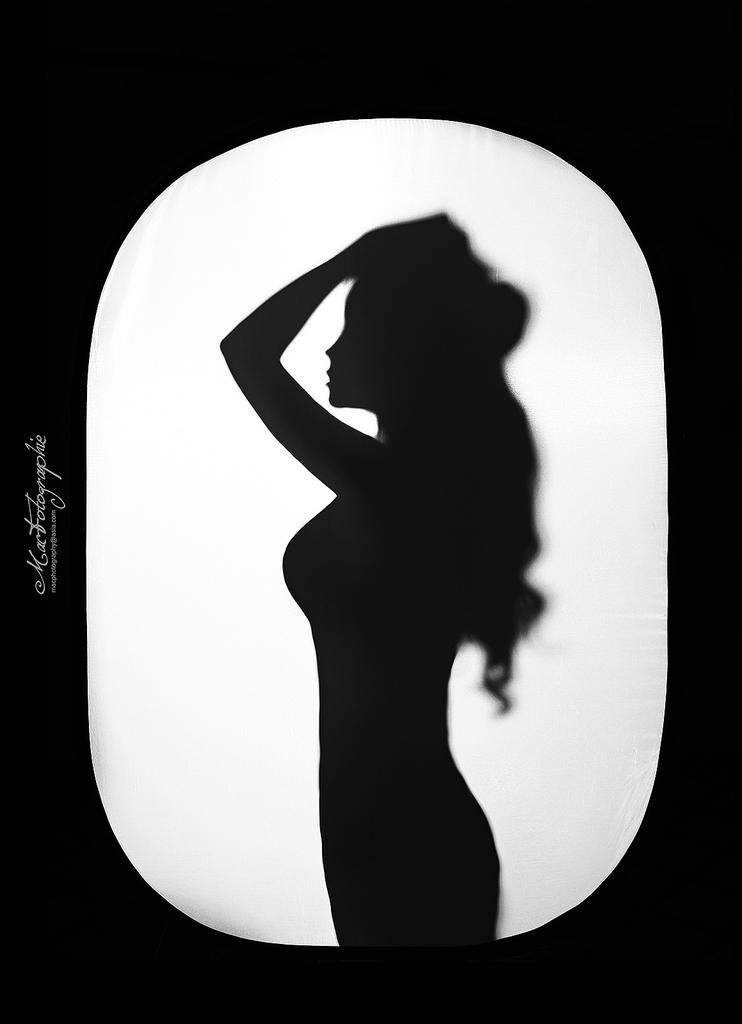What is the main subject of the image? The main subject of the image is a silhouette. Can you describe any additional elements in the image? There is written text on the left side of the image. What type of slope can be seen in the image? There is no slope present in the image; it features a silhouette and written text. How many arms does the person in the silhouette have? The silhouette is not detailed enough to determine the number of arms, as it is a simple outline. 